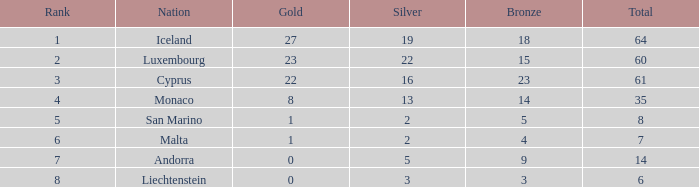What is iceland's ranking in terms of under 19 silver medals? None. 